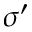<formula> <loc_0><loc_0><loc_500><loc_500>\sigma ^ { \prime }</formula> 